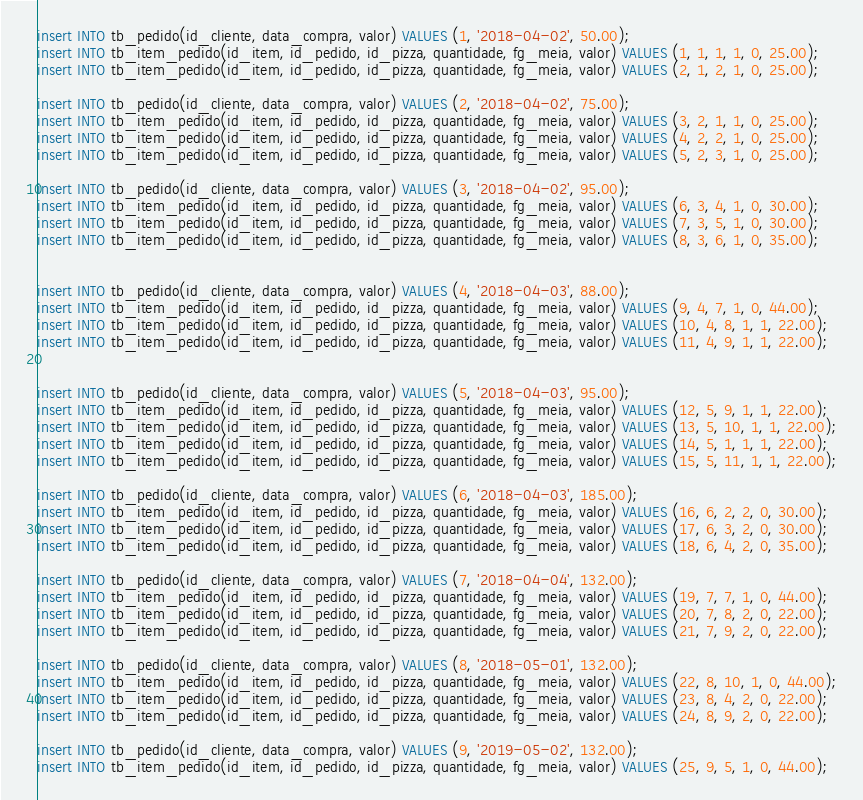Convert code to text. <code><loc_0><loc_0><loc_500><loc_500><_SQL_>insert INTO tb_pedido(id_cliente, data_compra, valor) VALUES (1, '2018-04-02', 50.00);
insert INTO tb_item_pedido(id_item, id_pedido, id_pizza, quantidade, fg_meia, valor) VALUES (1, 1, 1, 1, 0, 25.00);
insert INTO tb_item_pedido(id_item, id_pedido, id_pizza, quantidade, fg_meia, valor) VALUES (2, 1, 2, 1, 0, 25.00);

insert INTO tb_pedido(id_cliente, data_compra, valor) VALUES (2, '2018-04-02', 75.00);
insert INTO tb_item_pedido(id_item, id_pedido, id_pizza, quantidade, fg_meia, valor) VALUES (3, 2, 1, 1, 0, 25.00);
insert INTO tb_item_pedido(id_item, id_pedido, id_pizza, quantidade, fg_meia, valor) VALUES (4, 2, 2, 1, 0, 25.00);
insert INTO tb_item_pedido(id_item, id_pedido, id_pizza, quantidade, fg_meia, valor) VALUES (5, 2, 3, 1, 0, 25.00);

insert INTO tb_pedido(id_cliente, data_compra, valor) VALUES (3, '2018-04-02', 95.00);
insert INTO tb_item_pedido(id_item, id_pedido, id_pizza, quantidade, fg_meia, valor) VALUES (6, 3, 4, 1, 0, 30.00);
insert INTO tb_item_pedido(id_item, id_pedido, id_pizza, quantidade, fg_meia, valor) VALUES (7, 3, 5, 1, 0, 30.00);
insert INTO tb_item_pedido(id_item, id_pedido, id_pizza, quantidade, fg_meia, valor) VALUES (8, 3, 6, 1, 0, 35.00);


insert INTO tb_pedido(id_cliente, data_compra, valor) VALUES (4, '2018-04-03', 88.00);
insert INTO tb_item_pedido(id_item, id_pedido, id_pizza, quantidade, fg_meia, valor) VALUES (9, 4, 7, 1, 0, 44.00);
insert INTO tb_item_pedido(id_item, id_pedido, id_pizza, quantidade, fg_meia, valor) VALUES (10, 4, 8, 1, 1, 22.00);
insert INTO tb_item_pedido(id_item, id_pedido, id_pizza, quantidade, fg_meia, valor) VALUES (11, 4, 9, 1, 1, 22.00);


insert INTO tb_pedido(id_cliente, data_compra, valor) VALUES (5, '2018-04-03', 95.00);
insert INTO tb_item_pedido(id_item, id_pedido, id_pizza, quantidade, fg_meia, valor) VALUES (12, 5, 9, 1, 1, 22.00);
insert INTO tb_item_pedido(id_item, id_pedido, id_pizza, quantidade, fg_meia, valor) VALUES (13, 5, 10, 1, 1, 22.00);
insert INTO tb_item_pedido(id_item, id_pedido, id_pizza, quantidade, fg_meia, valor) VALUES (14, 5, 1, 1, 1, 22.00);
insert INTO tb_item_pedido(id_item, id_pedido, id_pizza, quantidade, fg_meia, valor) VALUES (15, 5, 11, 1, 1, 22.00);

insert INTO tb_pedido(id_cliente, data_compra, valor) VALUES (6, '2018-04-03', 185.00);
insert INTO tb_item_pedido(id_item, id_pedido, id_pizza, quantidade, fg_meia, valor) VALUES (16, 6, 2, 2, 0, 30.00);
insert INTO tb_item_pedido(id_item, id_pedido, id_pizza, quantidade, fg_meia, valor) VALUES (17, 6, 3, 2, 0, 30.00);
insert INTO tb_item_pedido(id_item, id_pedido, id_pizza, quantidade, fg_meia, valor) VALUES (18, 6, 4, 2, 0, 35.00);

insert INTO tb_pedido(id_cliente, data_compra, valor) VALUES (7, '2018-04-04', 132.00);
insert INTO tb_item_pedido(id_item, id_pedido, id_pizza, quantidade, fg_meia, valor) VALUES (19, 7, 7, 1, 0, 44.00);
insert INTO tb_item_pedido(id_item, id_pedido, id_pizza, quantidade, fg_meia, valor) VALUES (20, 7, 8, 2, 0, 22.00);
insert INTO tb_item_pedido(id_item, id_pedido, id_pizza, quantidade, fg_meia, valor) VALUES (21, 7, 9, 2, 0, 22.00);

insert INTO tb_pedido(id_cliente, data_compra, valor) VALUES (8, '2018-05-01', 132.00);
insert INTO tb_item_pedido(id_item, id_pedido, id_pizza, quantidade, fg_meia, valor) VALUES (22, 8, 10, 1, 0, 44.00);
insert INTO tb_item_pedido(id_item, id_pedido, id_pizza, quantidade, fg_meia, valor) VALUES (23, 8, 4, 2, 0, 22.00);
insert INTO tb_item_pedido(id_item, id_pedido, id_pizza, quantidade, fg_meia, valor) VALUES (24, 8, 9, 2, 0, 22.00);

insert INTO tb_pedido(id_cliente, data_compra, valor) VALUES (9, '2019-05-02', 132.00);
insert INTO tb_item_pedido(id_item, id_pedido, id_pizza, quantidade, fg_meia, valor) VALUES (25, 9, 5, 1, 0, 44.00);</code> 